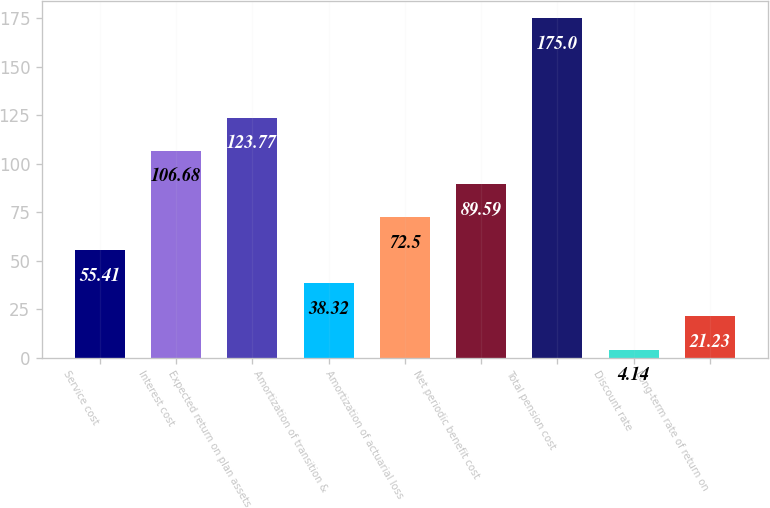Convert chart. <chart><loc_0><loc_0><loc_500><loc_500><bar_chart><fcel>Service cost<fcel>Interest cost<fcel>Expected return on plan assets<fcel>Amortization of transition &<fcel>Amortization of actuarial loss<fcel>Net periodic benefit cost<fcel>Total pension cost<fcel>Discount rate<fcel>Long-term rate of return on<nl><fcel>55.41<fcel>106.68<fcel>123.77<fcel>38.32<fcel>72.5<fcel>89.59<fcel>175<fcel>4.14<fcel>21.23<nl></chart> 